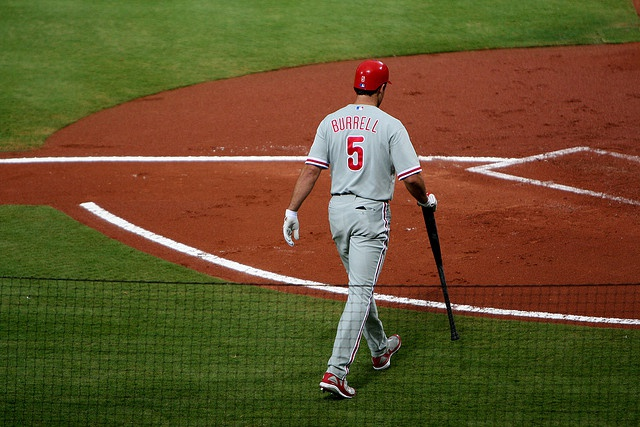Describe the objects in this image and their specific colors. I can see people in darkgreen, darkgray, lightblue, lightgray, and black tones and baseball bat in darkgreen, black, maroon, and brown tones in this image. 